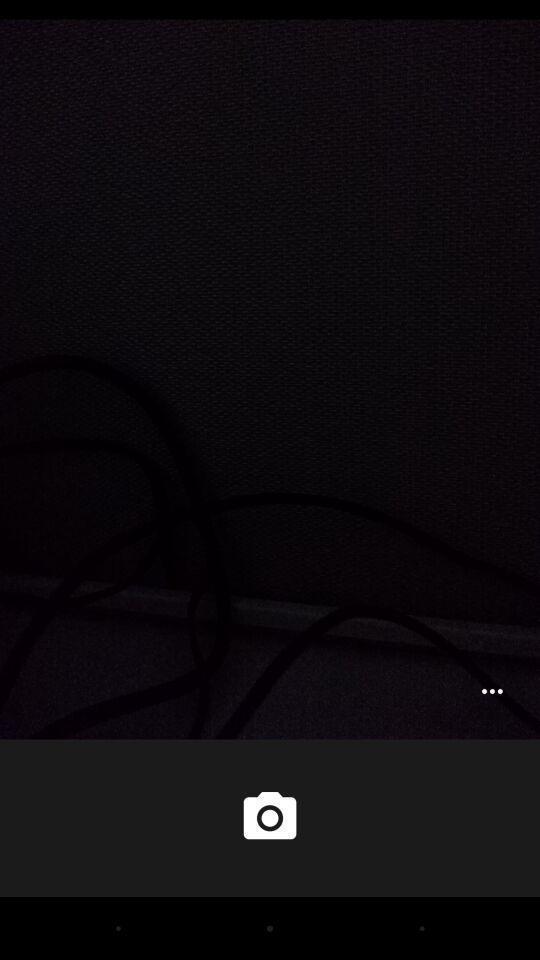Give me a narrative description of this picture. Open page of camera in the app. 